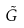<formula> <loc_0><loc_0><loc_500><loc_500>\tilde { G }</formula> 